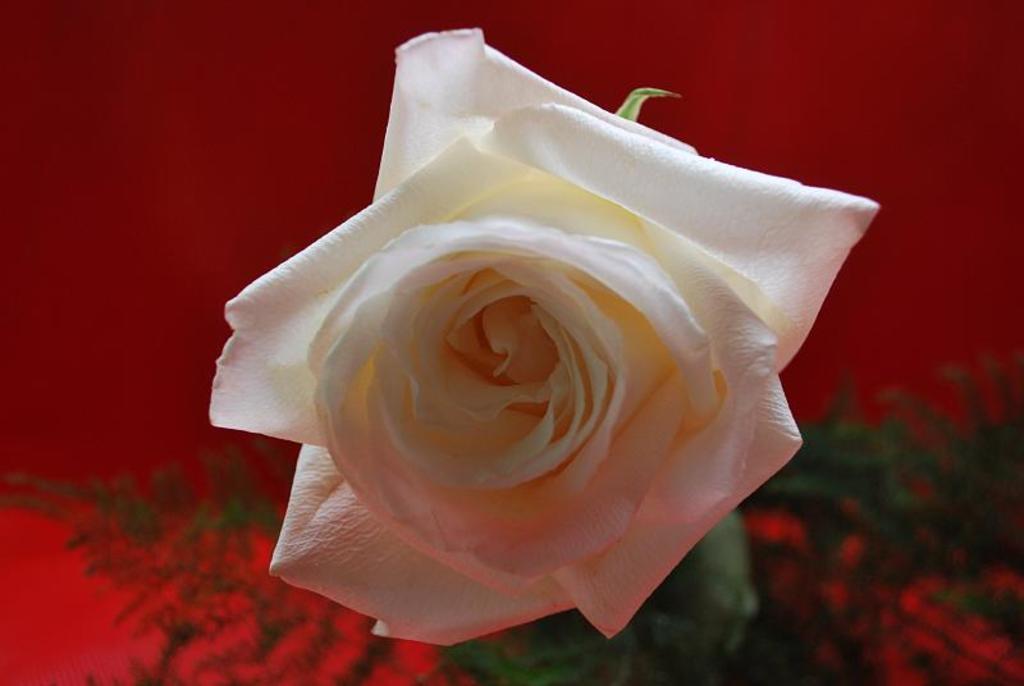Please provide a concise description of this image. In this image we can see a flower. In the background the image is not clear but we can see planets and red color object. 